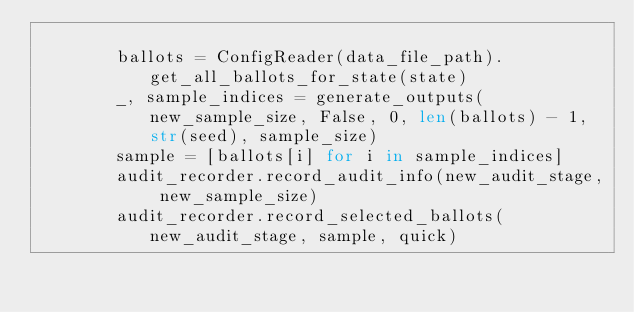<code> <loc_0><loc_0><loc_500><loc_500><_Python_>
        ballots = ConfigReader(data_file_path).get_all_ballots_for_state(state)
        _, sample_indices = generate_outputs(new_sample_size, False, 0, len(ballots) - 1, str(seed), sample_size)
        sample = [ballots[i] for i in sample_indices]
        audit_recorder.record_audit_info(new_audit_stage, new_sample_size)
        audit_recorder.record_selected_ballots(new_audit_stage, sample, quick)
</code> 